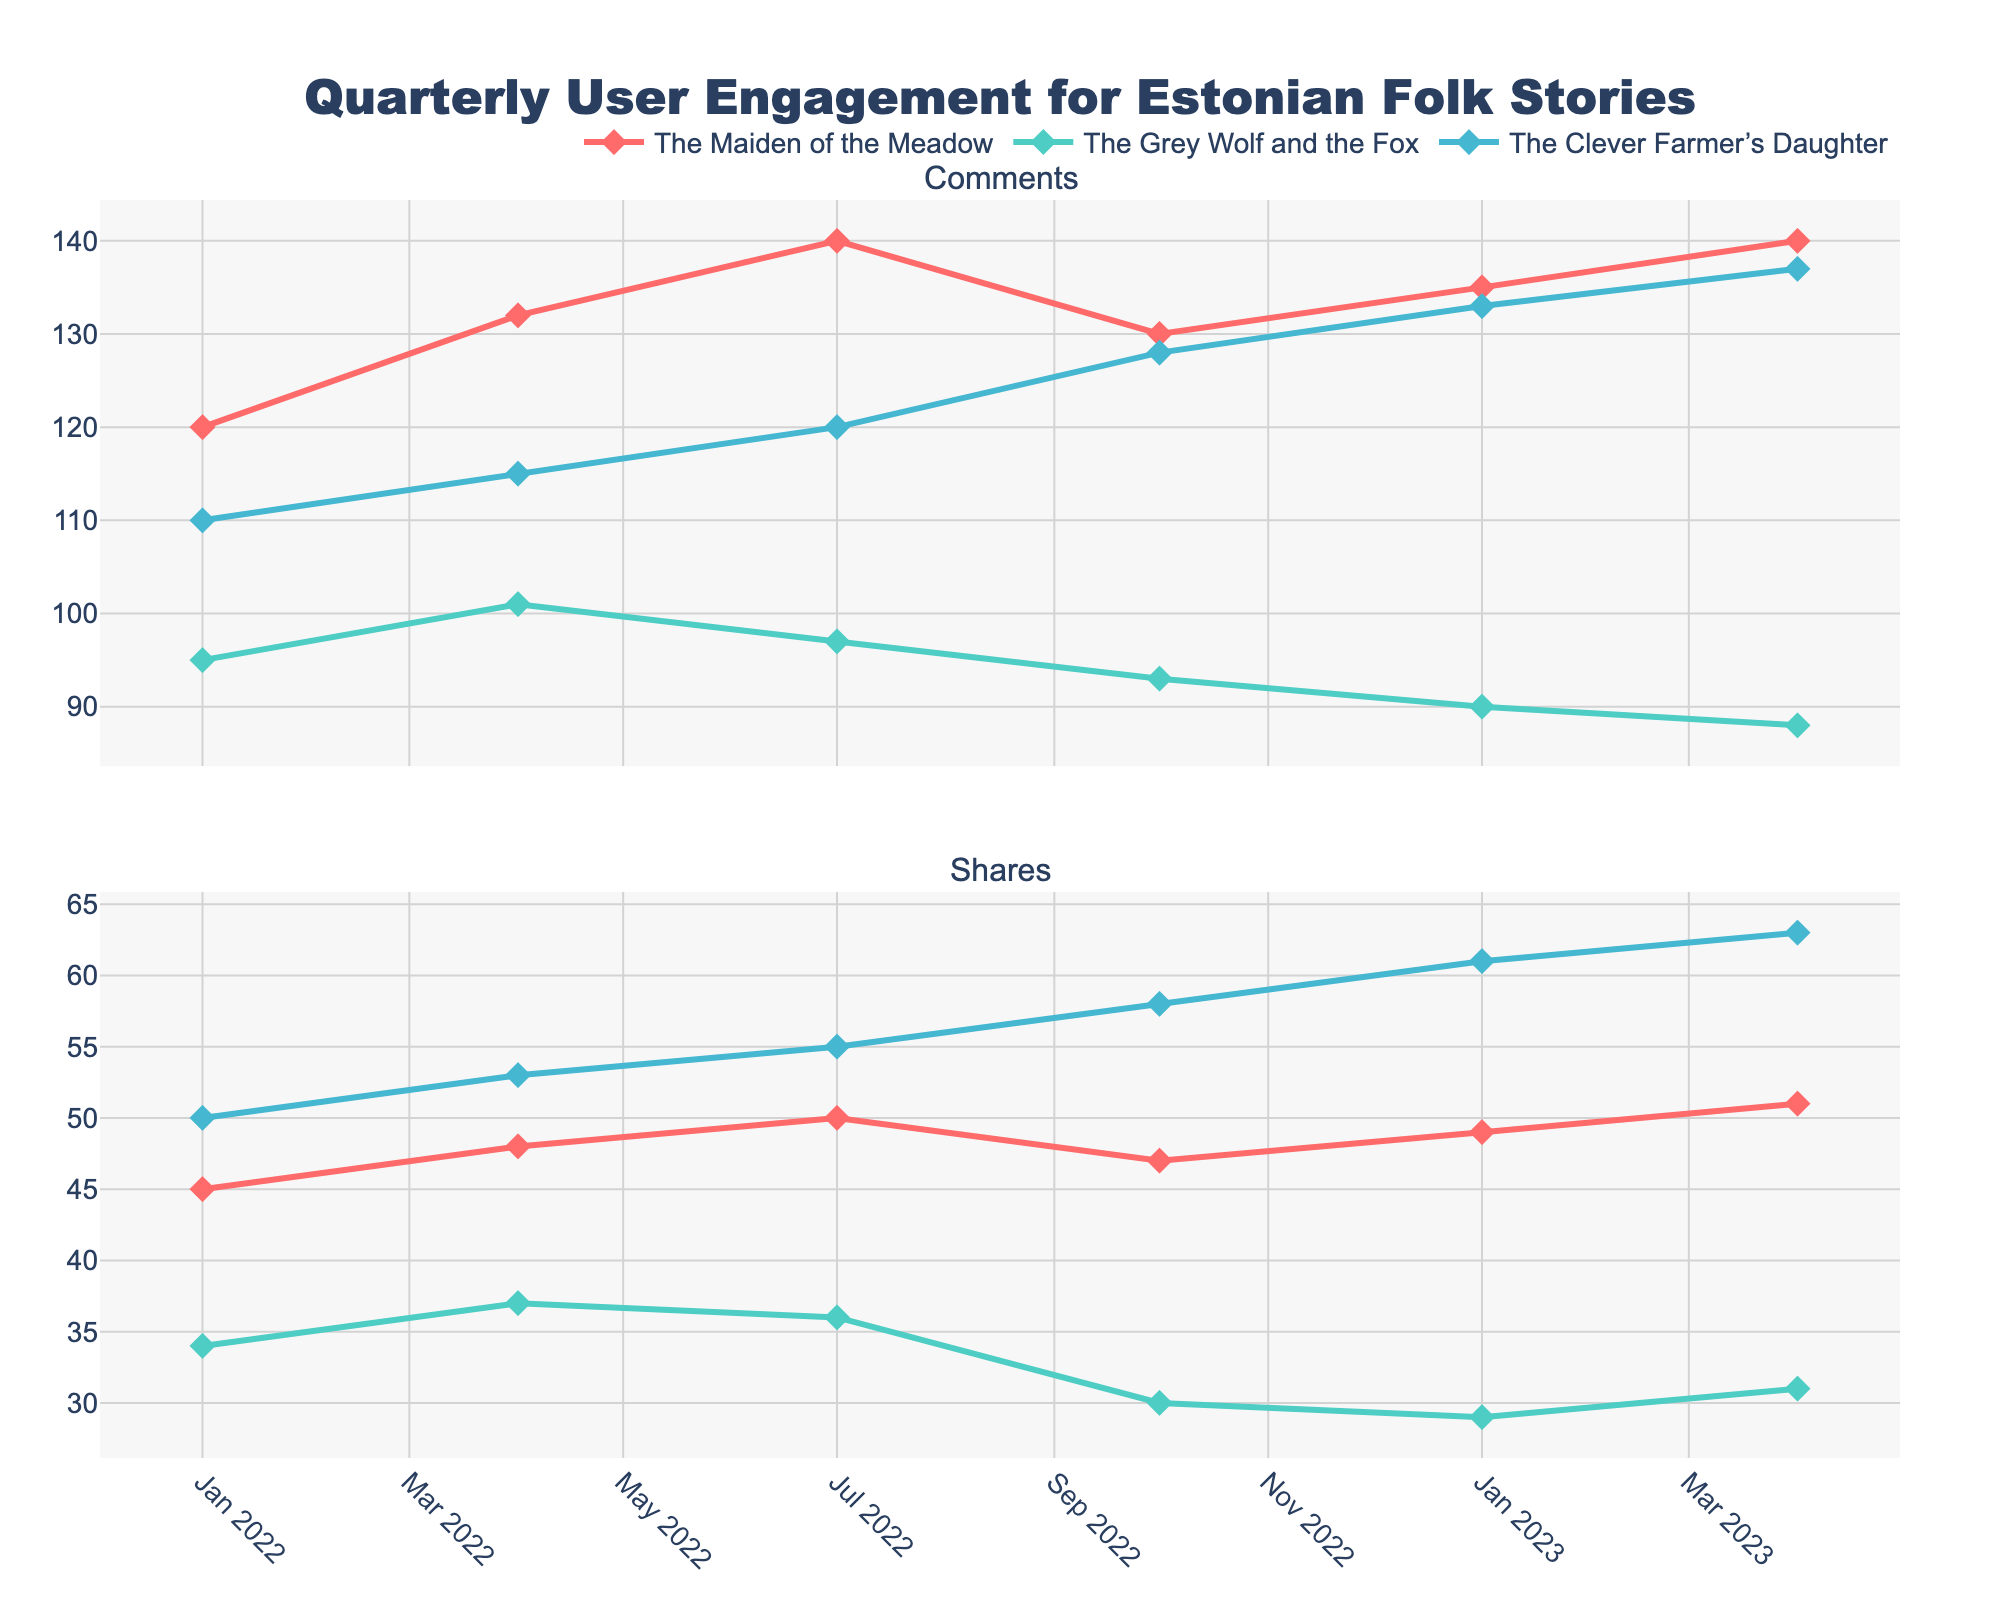What's the title of the figure? The title of the figure is at the top center, clearly stating the purpose of the figure.
Answer: Quarterly User Engagement for Estonian Folk Stories How many story titles are shown in the figure? The figure shows three different stories, and each one has its own line and color.
Answer: 3 Which quarter had the highest number of comments for "The Maiden of the Meadow"? Look at the Comments subplot and find the highest point for "The Maiden of the Meadow" (in the red line with diamond markers).
Answer: 2023-Q2 What are the total shares for "The Clever Farmer’s Daughter" in 2022? Add the share values for "The Clever Farmer’s Daughter" for each quarter in 2022. The values are 50, 53, 55, and 58.
Answer: 216 Did user engagement increase or decrease in terms of comments for "The Grey Wolf and the Fox" from 2022-Q4 to 2023-Q1? Compare the number of comments for "The Grey Wolf and the Fox" in 2022-Q4 and 2023-Q1. The values are 93 and 90 respectively.
Answer: Decrease Which story had the lowest number of shares in 2023-Q1? Check the Shares subplot for 2023-Q1 and identify the story with the lowest value.
Answer: The Grey Wolf and the Fox How does the trend of comments for "The Clever Farmer’s Daughter" compare to "The Grey Wolf and the Fox" in 2023? Compare the comment trends of "The Clever Farmer’s Daughter" and "The Grey Wolf and the Fox" in 2023. "The Clever Farmer’s Daughter" shows an upward trend, whereas "The Grey Wolf and the Fox" shows a downward trend.
Answer: The Clever Farmer’s Daughter increased, The Grey Wolf and the Fox decreased What is the average number of shares for "The Maiden of the Meadow" over the entire period? Calculate the average by adding all share values for "The Maiden of the Meadow" and dividing by the number of quarters. The values are 45, 48, 50, 47, 49, and 51. The sum is 290, and there are 6 quarters.
Answer: 48.33 Which story shows the most stable trend in shares over the period? Look for the line with the least fluctuation in the Shares subplot. "The Grey Wolf and the Fox" shows the most stable line as it fluctuates the least.
Answer: The Grey Wolf and the Fox In which quarter and for which story was the maximum user engagement observed in terms of comments? Check both subplots for the maximum number of comments. "The Clever Farmer’s Daughter" in 2023-Q2 has the highest comment count of 137.
Answer: 2023-Q2, The Clever Farmer’s Daughter 